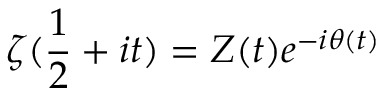Convert formula to latex. <formula><loc_0><loc_0><loc_500><loc_500>\zeta ( { \frac { 1 } { 2 } } + i t ) = Z ( t ) e ^ { - i \theta ( t ) }</formula> 